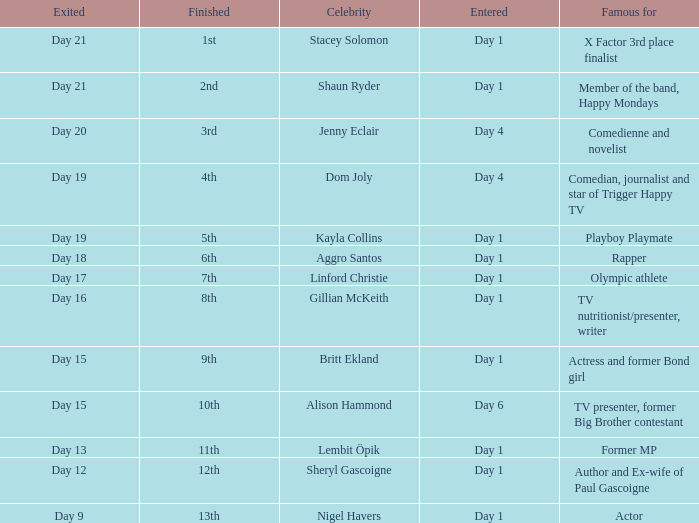What celebrity is famous for being an actor? Nigel Havers. 